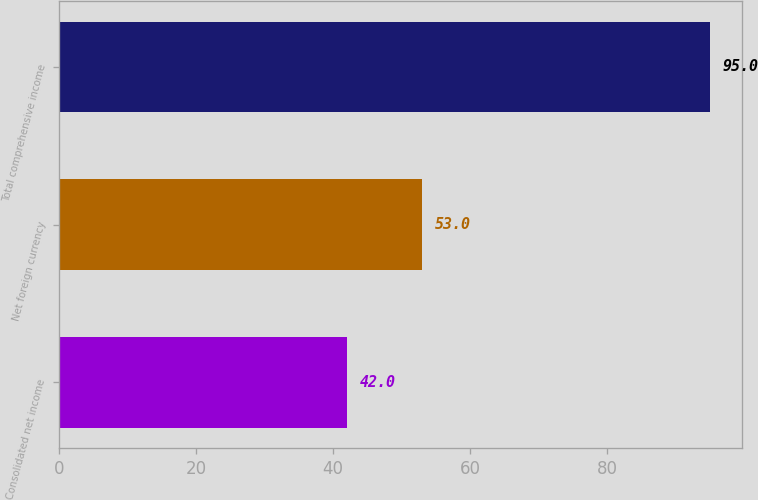Convert chart to OTSL. <chart><loc_0><loc_0><loc_500><loc_500><bar_chart><fcel>Consolidated net income<fcel>Net foreign currency<fcel>Total comprehensive income<nl><fcel>42<fcel>53<fcel>95<nl></chart> 